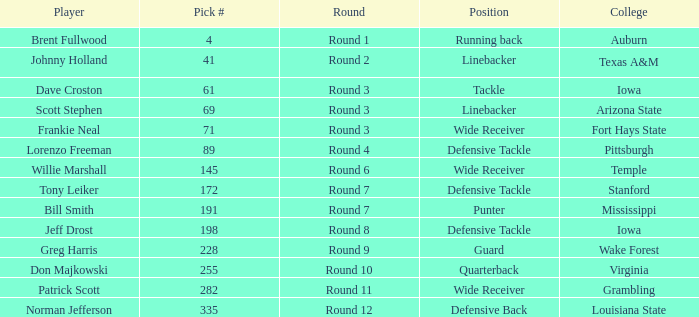Which college had Tony Leiker in round 7? Stanford. 